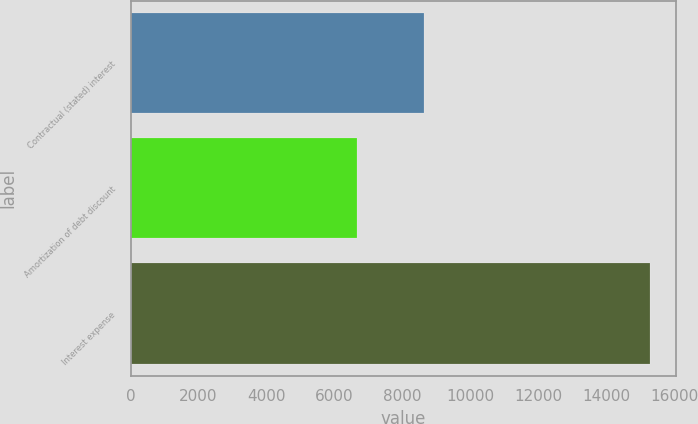Convert chart to OTSL. <chart><loc_0><loc_0><loc_500><loc_500><bar_chart><fcel>Contractual (stated) interest<fcel>Amortization of debt discount<fcel>Interest expense<nl><fcel>8625<fcel>6660<fcel>15285<nl></chart> 